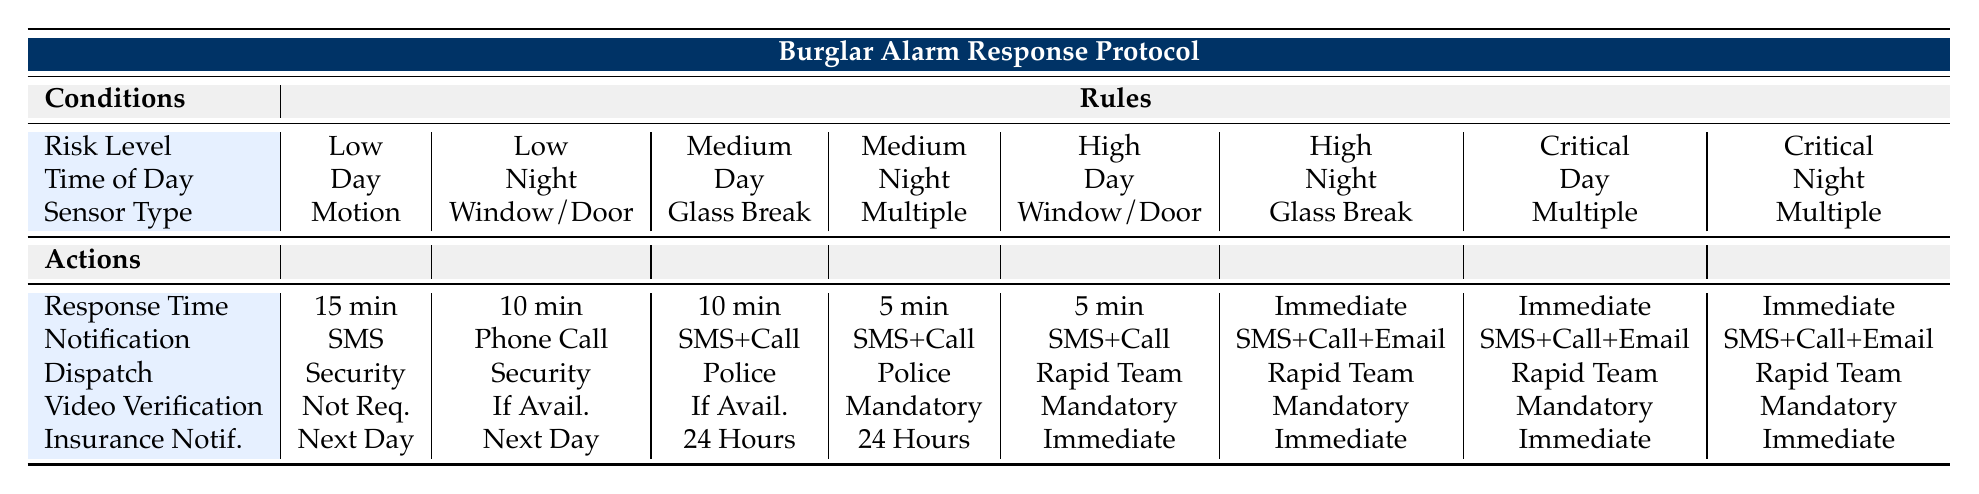What is the response time for a Medium risk level incident at night triggered by Multiple sensors? According to the table, for a Medium risk level incident at night with a Multiple sensor trigger, the response time is 5 minutes.
Answer: 5 minutes What notification method is used for Low risk incidents triggered by Motion sensors during the day? The table indicates that for Low risk incidents triggered by Motion sensors during the day, the notification method is SMS.
Answer: SMS Is it mandatory to have video verification for High risk incidents occurring at night with Glass Break sensors? The table shows that for High risk incidents at night with Glass Break sensors, video verification is mandatory, as indicated by "Mandatory" under Video Verification.
Answer: Yes What is the average response time for Critical risk incidents, both during the day and night? The response times for Critical incidents are Immediate for both day and night. Since Immediate can be considered as 0 minutes for calculation purposes, the average is (0 + 0) / 2 = 0 minutes.
Answer: 0 minutes How many total unique notification methods are listed in the table? The table lists four unique notification methods: SMS, Phone Call, SMS + Phone Call, and SMS + Phone Call + Email. Therefore, there are a total of four unique methods.
Answer: 4 For a Low risk incident at night with Window/Door sensors, who is dispatched according to the table? The table indicates that for a Low risk incident at night triggered by Window/Door sensors, a Security Guard is dispatched.
Answer: Security Guard Is there a scenario where the Insurance Company must be notified immediately? Yes, the table indicates that for High and Critical risk incidents both during the day and at night, the required notification time for the Insurance Company is Immediate.
Answer: Yes What is the difference in response time between High and Medium risk incidents during the day triggered by Window/Door sensors? The response time for High risk incidents is 5 minutes, while for Medium risk incidents it is 10 minutes. The difference is 10 - 5 = 5 minutes.
Answer: 5 minutes How many actions list 'SMS + Phone Call + Email' as notification for any risk level and time? The table shows that only High and Critical risk incidents, both during the day and night when Multiple sensors are triggered, have 'SMS + Phone Call + Email' as a notification method. This accounts for 4 instances.
Answer: 4 